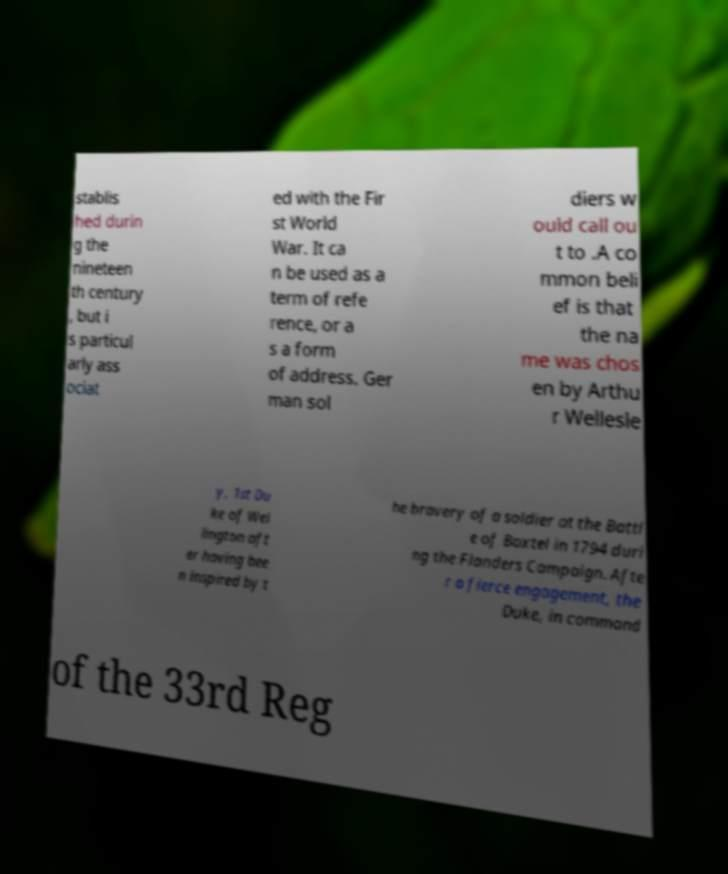I need the written content from this picture converted into text. Can you do that? stablis hed durin g the nineteen th century , but i s particul arly ass ociat ed with the Fir st World War. It ca n be used as a term of refe rence, or a s a form of address. Ger man sol diers w ould call ou t to .A co mmon beli ef is that the na me was chos en by Arthu r Wellesle y, 1st Du ke of Wel lington aft er having bee n inspired by t he bravery of a soldier at the Battl e of Boxtel in 1794 duri ng the Flanders Campaign. Afte r a fierce engagement, the Duke, in command of the 33rd Reg 